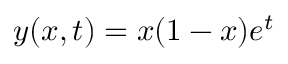Convert formula to latex. <formula><loc_0><loc_0><loc_500><loc_500>y ( x , t ) = x ( 1 - x ) e ^ { t }</formula> 